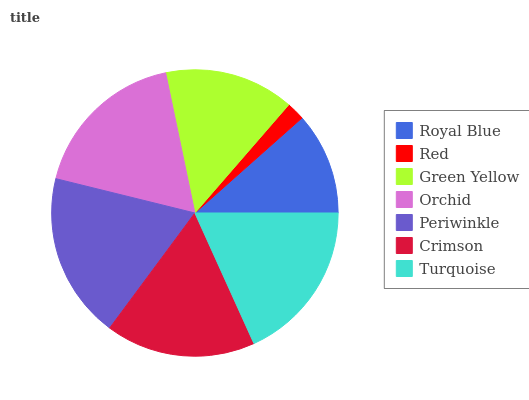Is Red the minimum?
Answer yes or no. Yes. Is Periwinkle the maximum?
Answer yes or no. Yes. Is Green Yellow the minimum?
Answer yes or no. No. Is Green Yellow the maximum?
Answer yes or no. No. Is Green Yellow greater than Red?
Answer yes or no. Yes. Is Red less than Green Yellow?
Answer yes or no. Yes. Is Red greater than Green Yellow?
Answer yes or no. No. Is Green Yellow less than Red?
Answer yes or no. No. Is Crimson the high median?
Answer yes or no. Yes. Is Crimson the low median?
Answer yes or no. Yes. Is Turquoise the high median?
Answer yes or no. No. Is Royal Blue the low median?
Answer yes or no. No. 